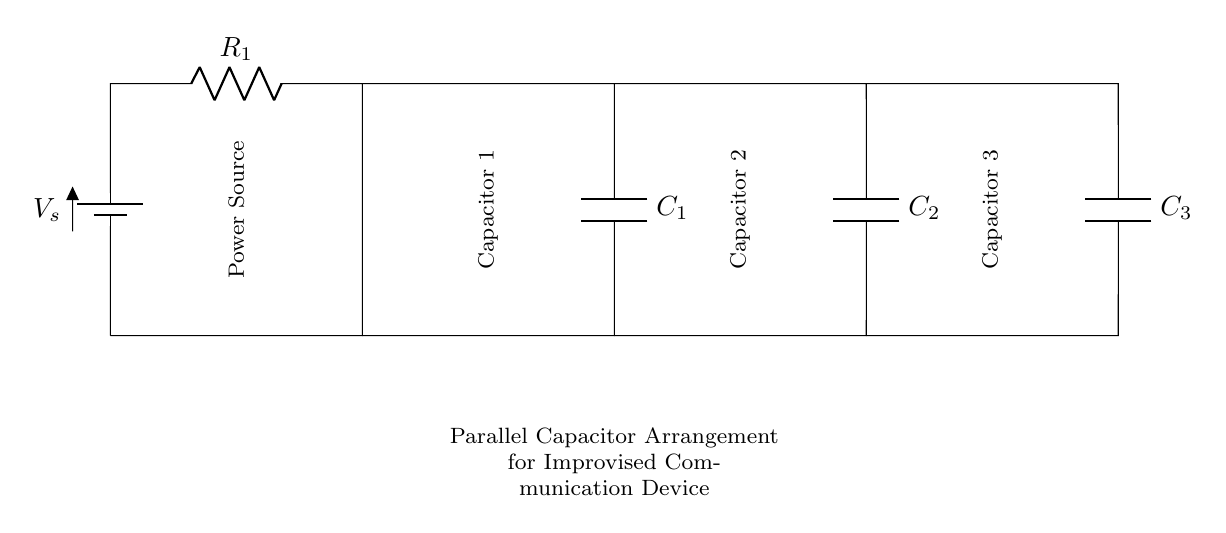What is the total number of capacitors in the circuit? The circuit diagram shows three capacitors connected in parallel. We can count them visually as C1, C2, and C3.
Answer: three What type of arrangement is used for the capacitors? The diagram clearly indicates that the capacitors are connected side by side without any other components interrupting their connections. This visual arrangement signifies a parallel connection.
Answer: parallel What component type is R1 in this circuit? The diagram highlights R1 as a resistor; this is easily identifiable at the top of the circuit where it is labeled.
Answer: resistor What is the function of the capacitors in this application? In this context, capacitors serve to store charge and help in smoothing out voltage fluctuations in communication devices. This is implied by their arrangement and purpose described in the diagram's title.
Answer: storing charge How does the equivalent capacitance of this arrangement compare to individual capacitances? In a parallel arrangement, the equivalent capacitance is the sum of individual capacitances. This is a fundamental property of capacitors in parallel; hence, we can deduce the relationship without complex calculations.
Answer: sum of individual capacitances What could be the role of the battery in this circuit? The battery is the power source, which provides the necessary voltage for the circuit to function. Its placement at the start of the circuit indicates its role in energizing the entire arrangement, powering both resistors and capacitors.
Answer: power source What effect does connecting capacitors in parallel have on voltage across them? When capacitors are in parallel, they all experience the same voltage across their terminals. This is clear from the schematic where branches from the voltage source connect directly to each capacitor without any voltage drop between them.
Answer: same voltage 